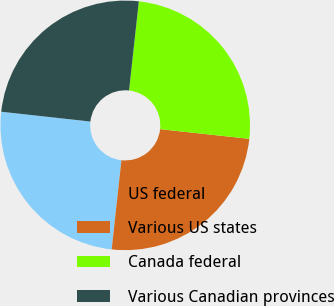Convert chart. <chart><loc_0><loc_0><loc_500><loc_500><pie_chart><fcel>US federal<fcel>Various US states<fcel>Canada federal<fcel>Various Canadian provinces<nl><fcel>25.01%<fcel>25.01%<fcel>24.99%<fcel>24.99%<nl></chart> 